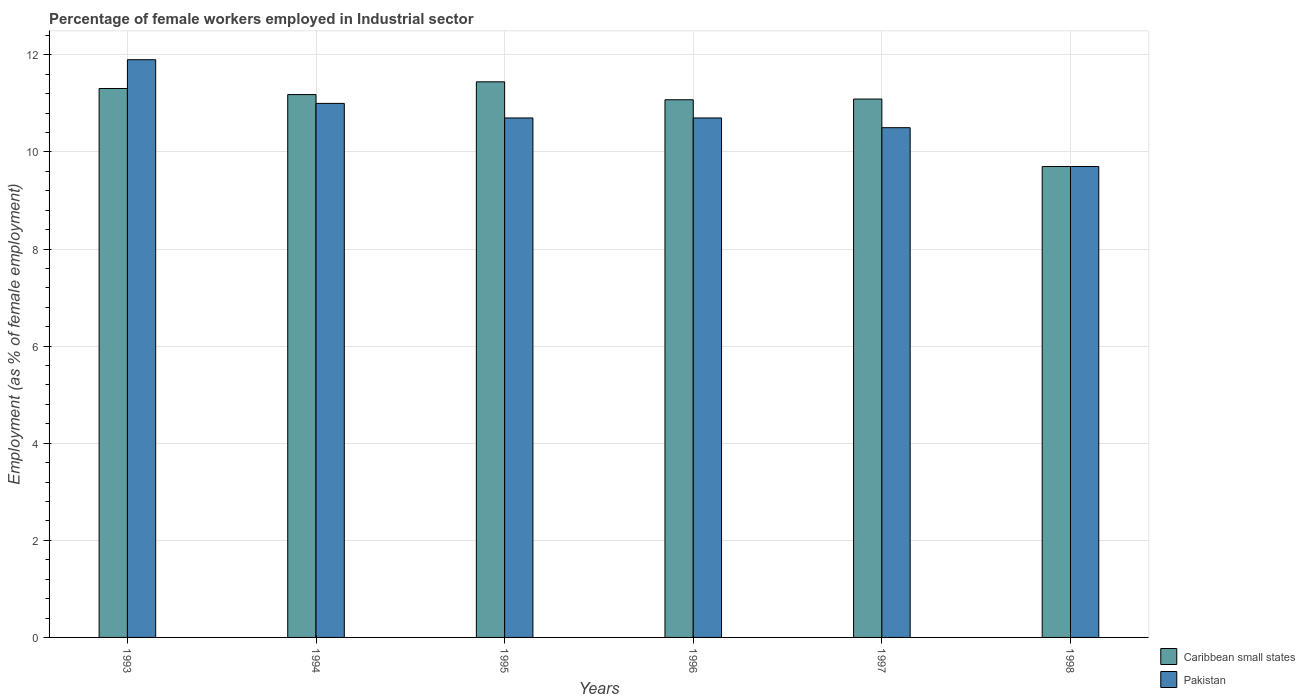How many groups of bars are there?
Offer a terse response. 6. Are the number of bars per tick equal to the number of legend labels?
Your response must be concise. Yes. Are the number of bars on each tick of the X-axis equal?
Keep it short and to the point. Yes. What is the percentage of females employed in Industrial sector in Caribbean small states in 1994?
Make the answer very short. 11.18. Across all years, what is the maximum percentage of females employed in Industrial sector in Pakistan?
Your answer should be compact. 11.9. Across all years, what is the minimum percentage of females employed in Industrial sector in Pakistan?
Provide a short and direct response. 9.7. In which year was the percentage of females employed in Industrial sector in Caribbean small states minimum?
Ensure brevity in your answer.  1998. What is the total percentage of females employed in Industrial sector in Caribbean small states in the graph?
Your answer should be very brief. 65.8. What is the difference between the percentage of females employed in Industrial sector in Caribbean small states in 1995 and that in 1996?
Give a very brief answer. 0.37. What is the difference between the percentage of females employed in Industrial sector in Caribbean small states in 1997 and the percentage of females employed in Industrial sector in Pakistan in 1994?
Your response must be concise. 0.09. What is the average percentage of females employed in Industrial sector in Pakistan per year?
Provide a short and direct response. 10.75. In the year 1994, what is the difference between the percentage of females employed in Industrial sector in Caribbean small states and percentage of females employed in Industrial sector in Pakistan?
Give a very brief answer. 0.18. What is the ratio of the percentage of females employed in Industrial sector in Caribbean small states in 1995 to that in 1996?
Provide a short and direct response. 1.03. Is the percentage of females employed in Industrial sector in Pakistan in 1993 less than that in 1997?
Your answer should be very brief. No. What is the difference between the highest and the second highest percentage of females employed in Industrial sector in Pakistan?
Ensure brevity in your answer.  0.9. What is the difference between the highest and the lowest percentage of females employed in Industrial sector in Pakistan?
Provide a short and direct response. 2.2. What does the 1st bar from the left in 1994 represents?
Ensure brevity in your answer.  Caribbean small states. How many bars are there?
Keep it short and to the point. 12. Does the graph contain any zero values?
Ensure brevity in your answer.  No. Does the graph contain grids?
Make the answer very short. Yes. What is the title of the graph?
Give a very brief answer. Percentage of female workers employed in Industrial sector. What is the label or title of the X-axis?
Give a very brief answer. Years. What is the label or title of the Y-axis?
Provide a short and direct response. Employment (as % of female employment). What is the Employment (as % of female employment) of Caribbean small states in 1993?
Your answer should be very brief. 11.31. What is the Employment (as % of female employment) in Pakistan in 1993?
Provide a succinct answer. 11.9. What is the Employment (as % of female employment) of Caribbean small states in 1994?
Make the answer very short. 11.18. What is the Employment (as % of female employment) of Caribbean small states in 1995?
Keep it short and to the point. 11.44. What is the Employment (as % of female employment) of Pakistan in 1995?
Ensure brevity in your answer.  10.7. What is the Employment (as % of female employment) of Caribbean small states in 1996?
Make the answer very short. 11.07. What is the Employment (as % of female employment) of Pakistan in 1996?
Your answer should be very brief. 10.7. What is the Employment (as % of female employment) in Caribbean small states in 1997?
Your answer should be compact. 11.09. What is the Employment (as % of female employment) in Caribbean small states in 1998?
Your response must be concise. 9.7. What is the Employment (as % of female employment) of Pakistan in 1998?
Your answer should be very brief. 9.7. Across all years, what is the maximum Employment (as % of female employment) in Caribbean small states?
Provide a succinct answer. 11.44. Across all years, what is the maximum Employment (as % of female employment) in Pakistan?
Your answer should be compact. 11.9. Across all years, what is the minimum Employment (as % of female employment) of Caribbean small states?
Give a very brief answer. 9.7. Across all years, what is the minimum Employment (as % of female employment) in Pakistan?
Offer a very short reply. 9.7. What is the total Employment (as % of female employment) in Caribbean small states in the graph?
Your answer should be compact. 65.8. What is the total Employment (as % of female employment) in Pakistan in the graph?
Offer a terse response. 64.5. What is the difference between the Employment (as % of female employment) in Caribbean small states in 1993 and that in 1994?
Your answer should be compact. 0.13. What is the difference between the Employment (as % of female employment) in Caribbean small states in 1993 and that in 1995?
Ensure brevity in your answer.  -0.14. What is the difference between the Employment (as % of female employment) of Pakistan in 1993 and that in 1995?
Offer a very short reply. 1.2. What is the difference between the Employment (as % of female employment) of Caribbean small states in 1993 and that in 1996?
Provide a succinct answer. 0.23. What is the difference between the Employment (as % of female employment) in Caribbean small states in 1993 and that in 1997?
Make the answer very short. 0.22. What is the difference between the Employment (as % of female employment) of Caribbean small states in 1993 and that in 1998?
Ensure brevity in your answer.  1.61. What is the difference between the Employment (as % of female employment) in Pakistan in 1993 and that in 1998?
Your response must be concise. 2.2. What is the difference between the Employment (as % of female employment) in Caribbean small states in 1994 and that in 1995?
Keep it short and to the point. -0.26. What is the difference between the Employment (as % of female employment) in Pakistan in 1994 and that in 1995?
Your answer should be compact. 0.3. What is the difference between the Employment (as % of female employment) of Caribbean small states in 1994 and that in 1996?
Ensure brevity in your answer.  0.11. What is the difference between the Employment (as % of female employment) in Pakistan in 1994 and that in 1996?
Provide a short and direct response. 0.3. What is the difference between the Employment (as % of female employment) of Caribbean small states in 1994 and that in 1997?
Provide a short and direct response. 0.09. What is the difference between the Employment (as % of female employment) in Pakistan in 1994 and that in 1997?
Your answer should be compact. 0.5. What is the difference between the Employment (as % of female employment) of Caribbean small states in 1994 and that in 1998?
Offer a very short reply. 1.48. What is the difference between the Employment (as % of female employment) of Pakistan in 1994 and that in 1998?
Offer a terse response. 1.3. What is the difference between the Employment (as % of female employment) in Caribbean small states in 1995 and that in 1996?
Ensure brevity in your answer.  0.37. What is the difference between the Employment (as % of female employment) of Pakistan in 1995 and that in 1996?
Your answer should be compact. 0. What is the difference between the Employment (as % of female employment) in Caribbean small states in 1995 and that in 1997?
Provide a succinct answer. 0.35. What is the difference between the Employment (as % of female employment) of Caribbean small states in 1995 and that in 1998?
Offer a very short reply. 1.74. What is the difference between the Employment (as % of female employment) in Caribbean small states in 1996 and that in 1997?
Your answer should be compact. -0.01. What is the difference between the Employment (as % of female employment) in Pakistan in 1996 and that in 1997?
Ensure brevity in your answer.  0.2. What is the difference between the Employment (as % of female employment) in Caribbean small states in 1996 and that in 1998?
Ensure brevity in your answer.  1.37. What is the difference between the Employment (as % of female employment) in Caribbean small states in 1997 and that in 1998?
Your answer should be compact. 1.39. What is the difference between the Employment (as % of female employment) of Pakistan in 1997 and that in 1998?
Provide a short and direct response. 0.8. What is the difference between the Employment (as % of female employment) of Caribbean small states in 1993 and the Employment (as % of female employment) of Pakistan in 1994?
Your answer should be compact. 0.31. What is the difference between the Employment (as % of female employment) in Caribbean small states in 1993 and the Employment (as % of female employment) in Pakistan in 1995?
Your response must be concise. 0.61. What is the difference between the Employment (as % of female employment) of Caribbean small states in 1993 and the Employment (as % of female employment) of Pakistan in 1996?
Your answer should be compact. 0.61. What is the difference between the Employment (as % of female employment) in Caribbean small states in 1993 and the Employment (as % of female employment) in Pakistan in 1997?
Offer a very short reply. 0.81. What is the difference between the Employment (as % of female employment) in Caribbean small states in 1993 and the Employment (as % of female employment) in Pakistan in 1998?
Provide a succinct answer. 1.61. What is the difference between the Employment (as % of female employment) in Caribbean small states in 1994 and the Employment (as % of female employment) in Pakistan in 1995?
Offer a very short reply. 0.48. What is the difference between the Employment (as % of female employment) of Caribbean small states in 1994 and the Employment (as % of female employment) of Pakistan in 1996?
Ensure brevity in your answer.  0.48. What is the difference between the Employment (as % of female employment) of Caribbean small states in 1994 and the Employment (as % of female employment) of Pakistan in 1997?
Offer a terse response. 0.68. What is the difference between the Employment (as % of female employment) in Caribbean small states in 1994 and the Employment (as % of female employment) in Pakistan in 1998?
Keep it short and to the point. 1.48. What is the difference between the Employment (as % of female employment) of Caribbean small states in 1995 and the Employment (as % of female employment) of Pakistan in 1996?
Your answer should be compact. 0.74. What is the difference between the Employment (as % of female employment) of Caribbean small states in 1995 and the Employment (as % of female employment) of Pakistan in 1997?
Offer a terse response. 0.94. What is the difference between the Employment (as % of female employment) of Caribbean small states in 1995 and the Employment (as % of female employment) of Pakistan in 1998?
Ensure brevity in your answer.  1.74. What is the difference between the Employment (as % of female employment) in Caribbean small states in 1996 and the Employment (as % of female employment) in Pakistan in 1997?
Make the answer very short. 0.57. What is the difference between the Employment (as % of female employment) in Caribbean small states in 1996 and the Employment (as % of female employment) in Pakistan in 1998?
Provide a short and direct response. 1.38. What is the difference between the Employment (as % of female employment) in Caribbean small states in 1997 and the Employment (as % of female employment) in Pakistan in 1998?
Give a very brief answer. 1.39. What is the average Employment (as % of female employment) in Caribbean small states per year?
Give a very brief answer. 10.97. What is the average Employment (as % of female employment) in Pakistan per year?
Your response must be concise. 10.75. In the year 1993, what is the difference between the Employment (as % of female employment) of Caribbean small states and Employment (as % of female employment) of Pakistan?
Provide a succinct answer. -0.59. In the year 1994, what is the difference between the Employment (as % of female employment) in Caribbean small states and Employment (as % of female employment) in Pakistan?
Your answer should be very brief. 0.18. In the year 1995, what is the difference between the Employment (as % of female employment) in Caribbean small states and Employment (as % of female employment) in Pakistan?
Your answer should be compact. 0.74. In the year 1996, what is the difference between the Employment (as % of female employment) of Caribbean small states and Employment (as % of female employment) of Pakistan?
Offer a terse response. 0.38. In the year 1997, what is the difference between the Employment (as % of female employment) in Caribbean small states and Employment (as % of female employment) in Pakistan?
Give a very brief answer. 0.59. In the year 1998, what is the difference between the Employment (as % of female employment) in Caribbean small states and Employment (as % of female employment) in Pakistan?
Your answer should be very brief. 0. What is the ratio of the Employment (as % of female employment) in Caribbean small states in 1993 to that in 1994?
Give a very brief answer. 1.01. What is the ratio of the Employment (as % of female employment) in Pakistan in 1993 to that in 1994?
Ensure brevity in your answer.  1.08. What is the ratio of the Employment (as % of female employment) of Pakistan in 1993 to that in 1995?
Provide a succinct answer. 1.11. What is the ratio of the Employment (as % of female employment) of Caribbean small states in 1993 to that in 1996?
Offer a terse response. 1.02. What is the ratio of the Employment (as % of female employment) of Pakistan in 1993 to that in 1996?
Provide a succinct answer. 1.11. What is the ratio of the Employment (as % of female employment) of Caribbean small states in 1993 to that in 1997?
Provide a short and direct response. 1.02. What is the ratio of the Employment (as % of female employment) in Pakistan in 1993 to that in 1997?
Provide a succinct answer. 1.13. What is the ratio of the Employment (as % of female employment) in Caribbean small states in 1993 to that in 1998?
Offer a terse response. 1.17. What is the ratio of the Employment (as % of female employment) in Pakistan in 1993 to that in 1998?
Provide a succinct answer. 1.23. What is the ratio of the Employment (as % of female employment) in Caribbean small states in 1994 to that in 1995?
Keep it short and to the point. 0.98. What is the ratio of the Employment (as % of female employment) in Pakistan in 1994 to that in 1995?
Your answer should be compact. 1.03. What is the ratio of the Employment (as % of female employment) of Caribbean small states in 1994 to that in 1996?
Make the answer very short. 1.01. What is the ratio of the Employment (as % of female employment) in Pakistan in 1994 to that in 1996?
Offer a terse response. 1.03. What is the ratio of the Employment (as % of female employment) of Caribbean small states in 1994 to that in 1997?
Make the answer very short. 1.01. What is the ratio of the Employment (as % of female employment) in Pakistan in 1994 to that in 1997?
Ensure brevity in your answer.  1.05. What is the ratio of the Employment (as % of female employment) of Caribbean small states in 1994 to that in 1998?
Offer a very short reply. 1.15. What is the ratio of the Employment (as % of female employment) in Pakistan in 1994 to that in 1998?
Offer a very short reply. 1.13. What is the ratio of the Employment (as % of female employment) in Caribbean small states in 1995 to that in 1996?
Ensure brevity in your answer.  1.03. What is the ratio of the Employment (as % of female employment) of Caribbean small states in 1995 to that in 1997?
Your answer should be very brief. 1.03. What is the ratio of the Employment (as % of female employment) of Pakistan in 1995 to that in 1997?
Ensure brevity in your answer.  1.02. What is the ratio of the Employment (as % of female employment) in Caribbean small states in 1995 to that in 1998?
Provide a succinct answer. 1.18. What is the ratio of the Employment (as % of female employment) in Pakistan in 1995 to that in 1998?
Your response must be concise. 1.1. What is the ratio of the Employment (as % of female employment) in Caribbean small states in 1996 to that in 1998?
Offer a terse response. 1.14. What is the ratio of the Employment (as % of female employment) of Pakistan in 1996 to that in 1998?
Make the answer very short. 1.1. What is the ratio of the Employment (as % of female employment) of Caribbean small states in 1997 to that in 1998?
Offer a terse response. 1.14. What is the ratio of the Employment (as % of female employment) of Pakistan in 1997 to that in 1998?
Provide a succinct answer. 1.08. What is the difference between the highest and the second highest Employment (as % of female employment) of Caribbean small states?
Your response must be concise. 0.14. What is the difference between the highest and the lowest Employment (as % of female employment) of Caribbean small states?
Provide a short and direct response. 1.74. 